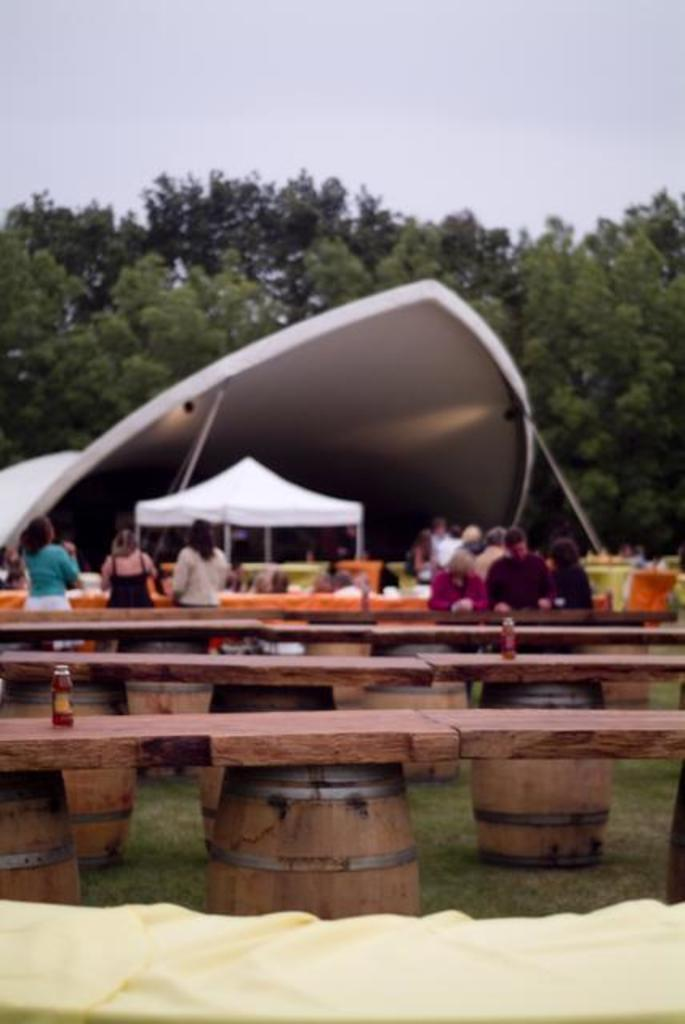What objects are on the table in the image? There are bottles on the table in the image. Can you describe the people in the background of the image? Unfortunately, the provided facts do not give any information about the people in the background. However, we can confirm that there are people standing in the background. What type of berry is being used to decorate the arch in the image? There is no arch or berry present in the image. 